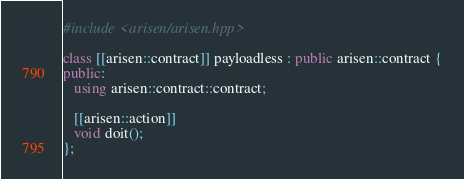Convert code to text. <code><loc_0><loc_0><loc_500><loc_500><_C++_>
#include <arisen/arisen.hpp>

class [[arisen::contract]] payloadless : public arisen::contract {
public:
   using arisen::contract::contract;

   [[arisen::action]]
   void doit();
};
</code> 